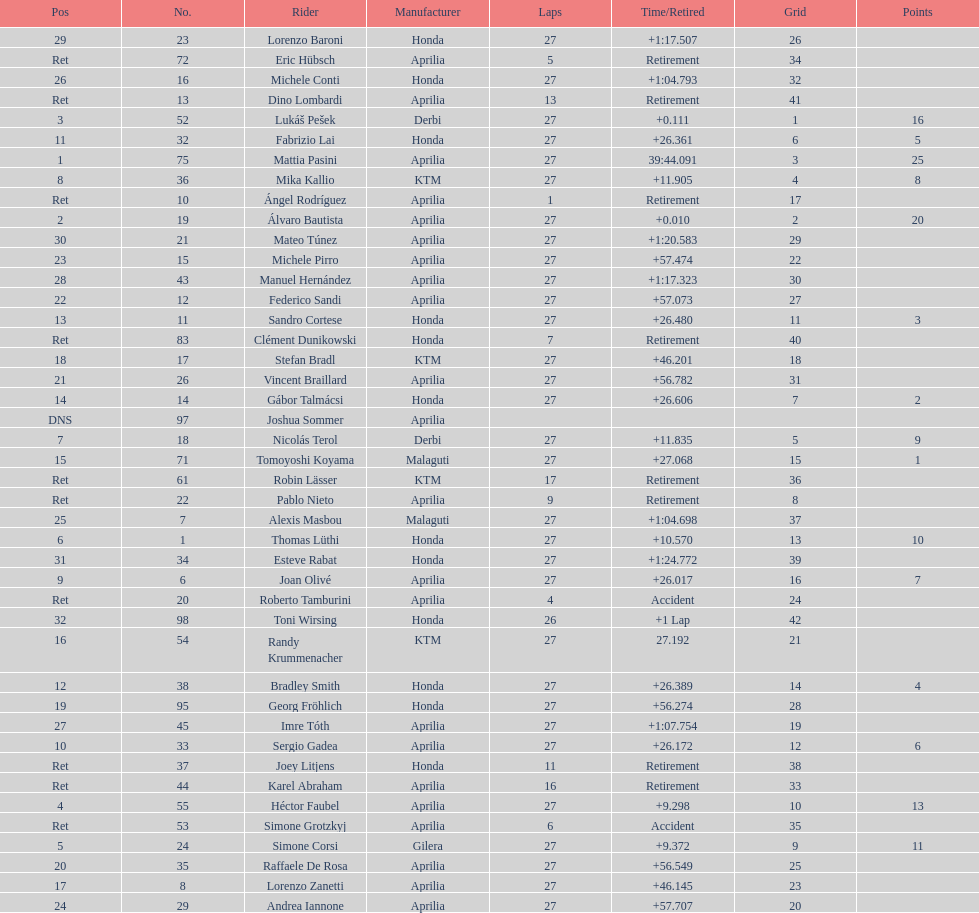Among individuals with points, who possesses the lowest amount? Tomoyoshi Koyama. 